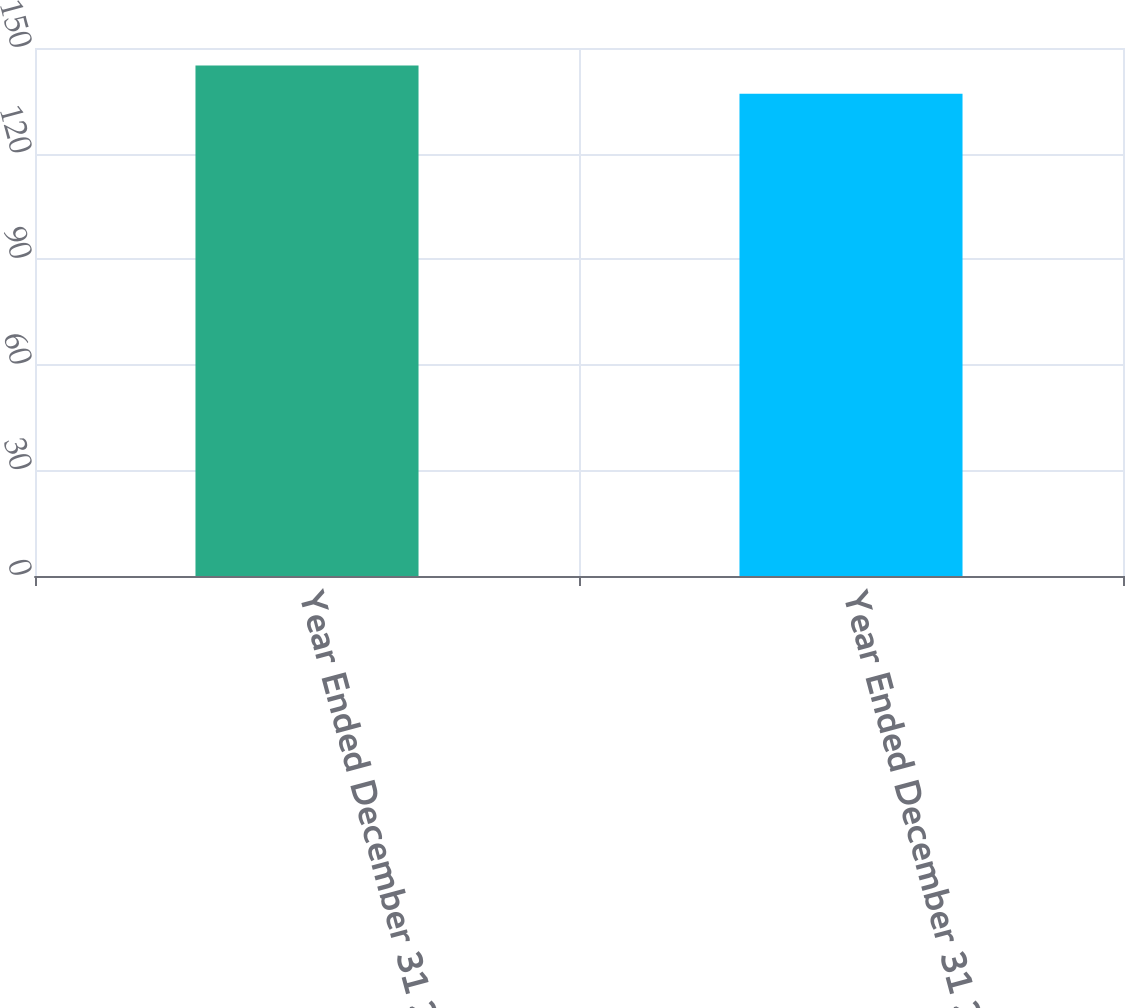Convert chart. <chart><loc_0><loc_0><loc_500><loc_500><bar_chart><fcel>Year Ended December 31 2010<fcel>Year Ended December 31 2009<nl><fcel>145<fcel>137<nl></chart> 